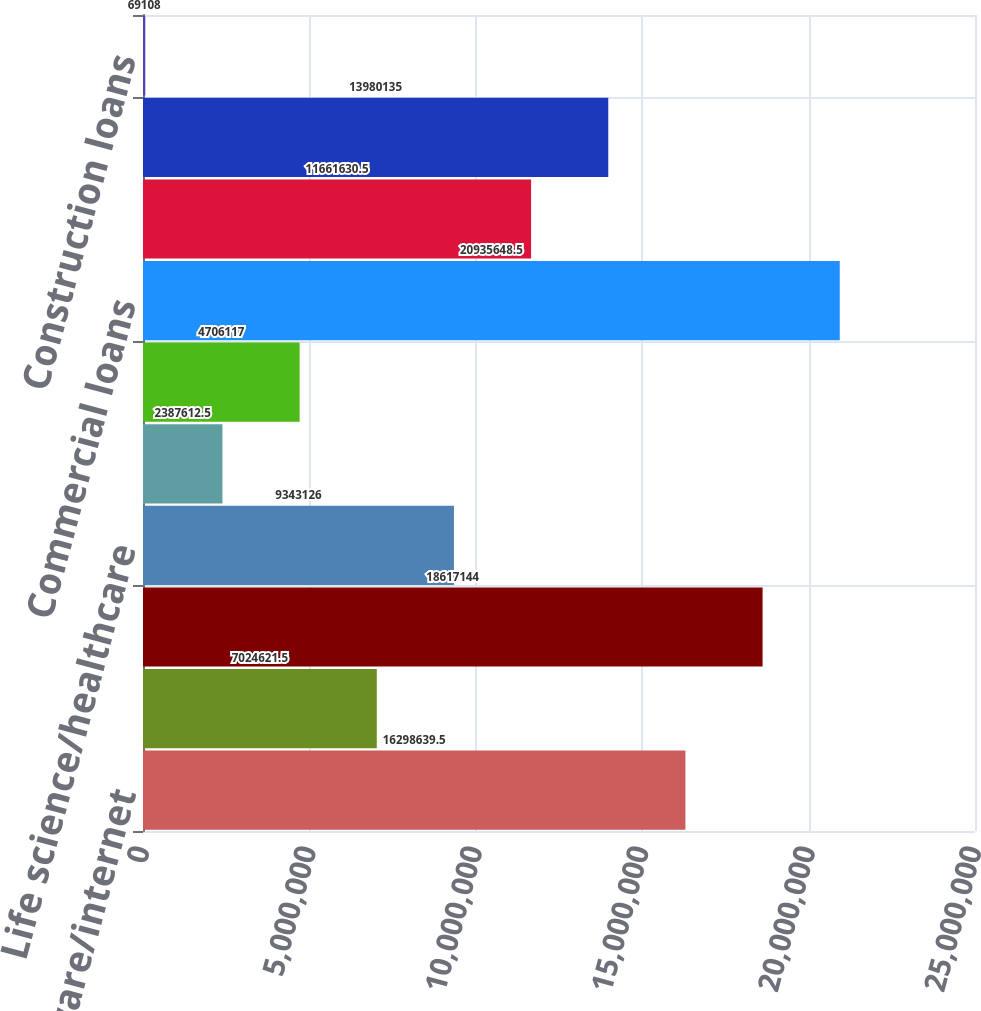<chart> <loc_0><loc_0><loc_500><loc_500><bar_chart><fcel>Software/internet<fcel>Hardware<fcel>Private equity/venture capital<fcel>Life science/healthcare<fcel>Premium wine<fcel>Other<fcel>Commercial loans<fcel>Consumer loans<fcel>Real estate secured loans<fcel>Construction loans<nl><fcel>1.62986e+07<fcel>7.02462e+06<fcel>1.86171e+07<fcel>9.34313e+06<fcel>2.38761e+06<fcel>4.70612e+06<fcel>2.09356e+07<fcel>1.16616e+07<fcel>1.39801e+07<fcel>69108<nl></chart> 